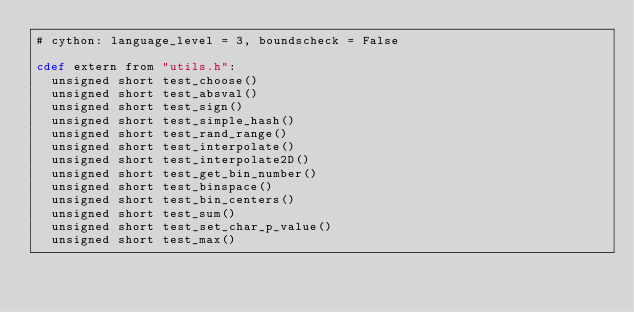Convert code to text. <code><loc_0><loc_0><loc_500><loc_500><_Cython_># cython: language_level = 3, boundscheck = False 

cdef extern from "utils.h": 
	unsigned short test_choose() 
	unsigned short test_absval() 
	unsigned short test_sign() 
	unsigned short test_simple_hash() 
	unsigned short test_rand_range() 
	unsigned short test_interpolate() 
	unsigned short test_interpolate2D() 
	unsigned short test_get_bin_number() 
	unsigned short test_binspace() 
	unsigned short test_bin_centers() 
	unsigned short test_sum() 
	unsigned short test_set_char_p_value() 
	unsigned short test_max() 
</code> 